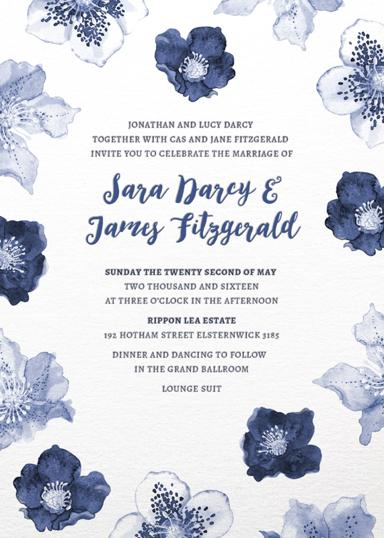What activities are planned for the wedding celebration? Post the wedding ceremony, the celebration continues with a dinner and a lively dancing session in the Grand Ballroom. Attendees are kindly requested to don lounge suits, blending elegance with comfort for an enjoyable evening. 